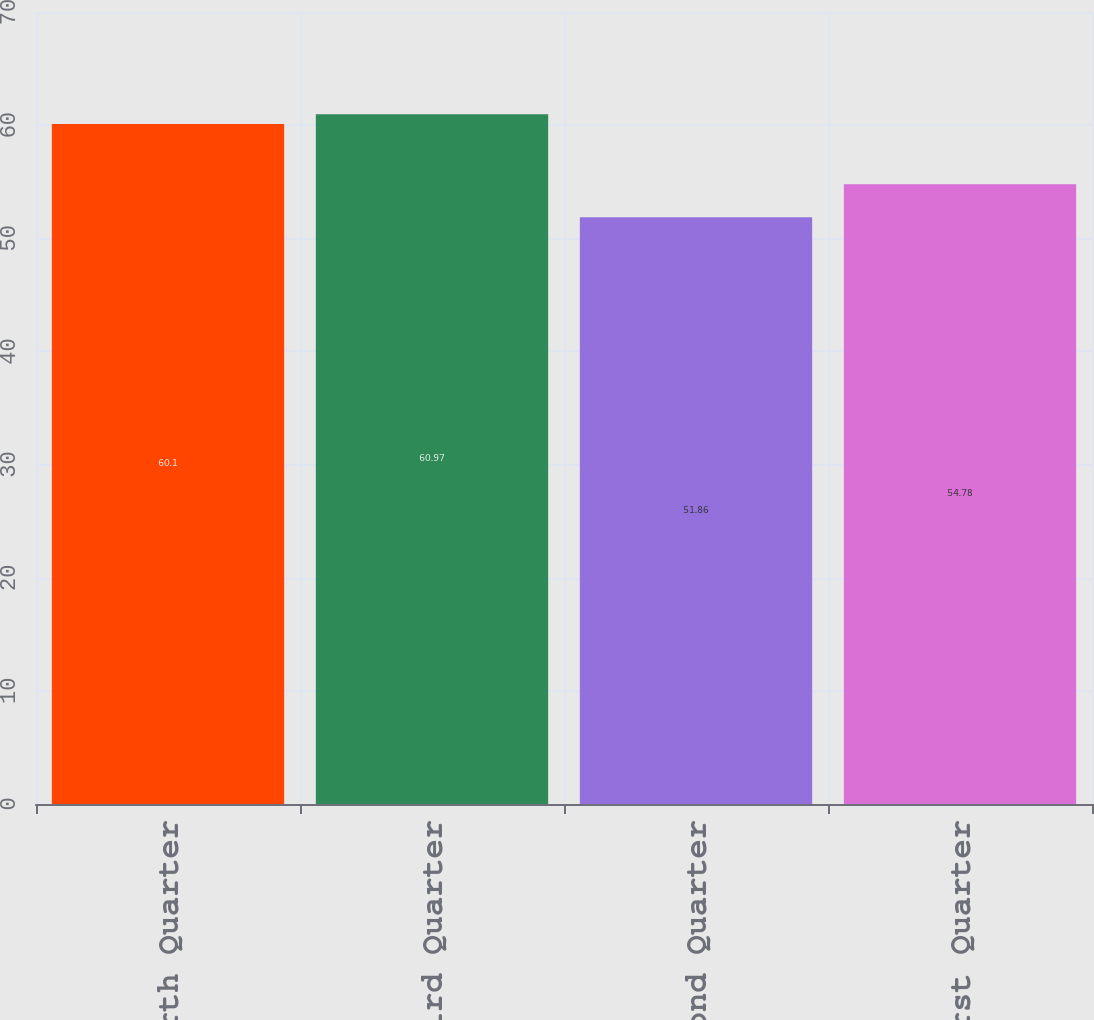Convert chart to OTSL. <chart><loc_0><loc_0><loc_500><loc_500><bar_chart><fcel>Fourth Quarter<fcel>Third Quarter<fcel>Second Quarter<fcel>First Quarter<nl><fcel>60.1<fcel>60.97<fcel>51.86<fcel>54.78<nl></chart> 